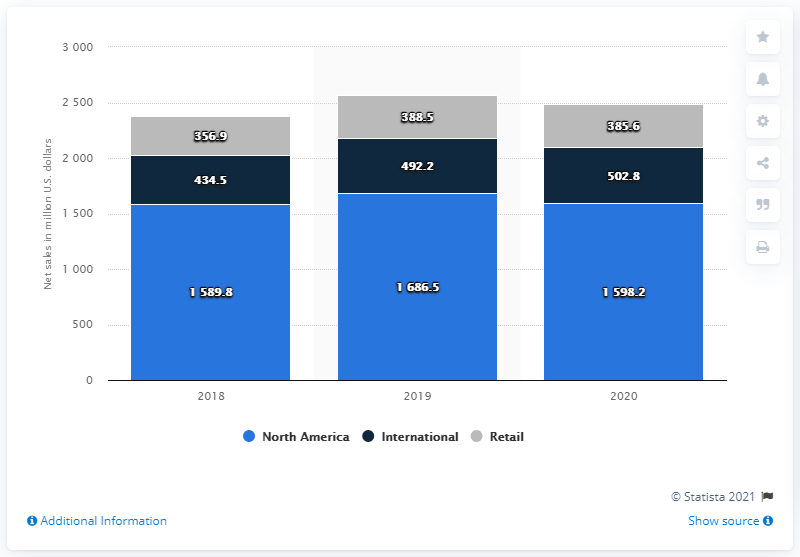Point out several critical features in this image. Retail accounts for approximately 15.51% of the economy in 2020. In fiscal year 2020, Herman Miller's net sales in North America were $1,598.2 million. The gray segments on the graph represent information related to retail, such as sales data, customer demographics, or market trends. 